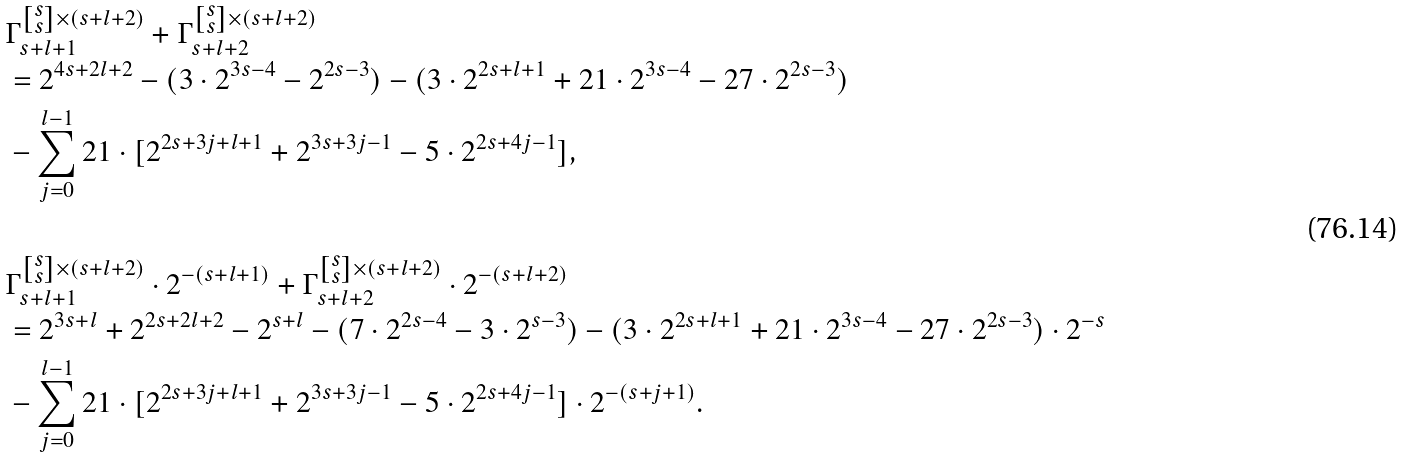Convert formula to latex. <formula><loc_0><loc_0><loc_500><loc_500>& \Gamma _ { s + l + 1 } ^ { \left [ \substack { s \\ s } \right ] \times ( s + l + 2 ) } + \Gamma _ { s + l + 2 } ^ { \left [ \substack { s \\ s } \right ] \times ( s + l + 2 ) } \\ & = 2 ^ { 4 s + 2 l + 2 } - ( 3 \cdot 2 ^ { 3 s - 4 } - 2 ^ { 2 s - 3 } ) - ( 3 \cdot 2 ^ { 2 s + l + 1 } + 2 1 \cdot 2 ^ { 3 s - 4 } - 2 7 \cdot 2 ^ { 2 s - 3 } ) \\ & - \sum _ { j = 0 } ^ { l - 1 } 2 1 \cdot [ 2 ^ { 2 s + 3 j + l + 1 } + 2 ^ { 3 s + 3 j - 1 } - 5 \cdot 2 ^ { 2 s + 4 j - 1 } ] , \\ & \\ & \Gamma _ { s + l + 1 } ^ { \left [ \substack { s \\ s } \right ] \times ( s + l + 2 ) } \cdot 2 ^ { - ( s + l + 1 ) } + \Gamma _ { s + l + 2 } ^ { \left [ \substack { s \\ s } \right ] \times ( s + l + 2 ) } \cdot 2 ^ { - ( s + l + 2 ) } \\ & = 2 ^ { 3 s + l } + 2 ^ { 2 s + 2 l + 2 } - 2 ^ { s + l } - ( 7 \cdot 2 ^ { 2 s - 4 } - 3 \cdot 2 ^ { s - 3 } ) - ( 3 \cdot 2 ^ { 2 s + l + 1 } + 2 1 \cdot 2 ^ { 3 s - 4 } - 2 7 \cdot 2 ^ { 2 s - 3 } ) \cdot 2 ^ { - s } \\ & - \sum _ { j = 0 } ^ { l - 1 } 2 1 \cdot [ 2 ^ { 2 s + 3 j + l + 1 } + 2 ^ { 3 s + 3 j - 1 } - 5 \cdot 2 ^ { 2 s + 4 j - 1 } ] \cdot 2 ^ { - ( s + j + 1 ) } .</formula> 